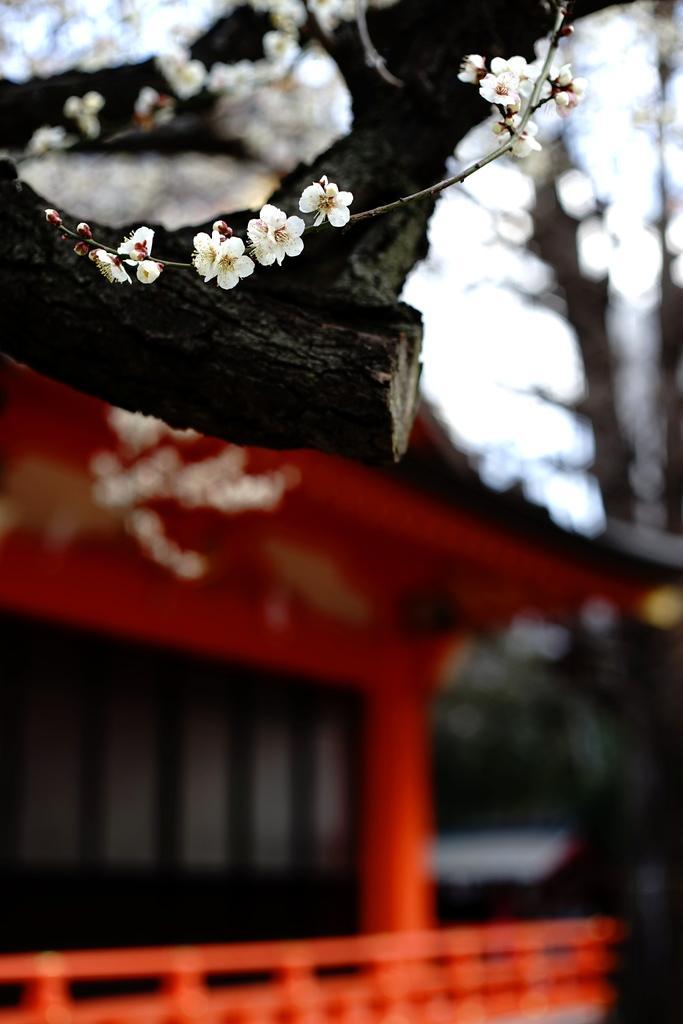Could you give a brief overview of what you see in this image? In this image, we can see few white flowers with stem and tree branch. Background there is a blur view. Here we can see house, trees, flowers and sky. 